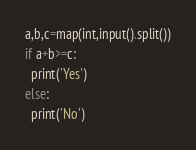Convert code to text. <code><loc_0><loc_0><loc_500><loc_500><_Python_>a,b,c=map(int,input().split())
if a+b>=c:
  print('Yes')
else:
  print('No')</code> 